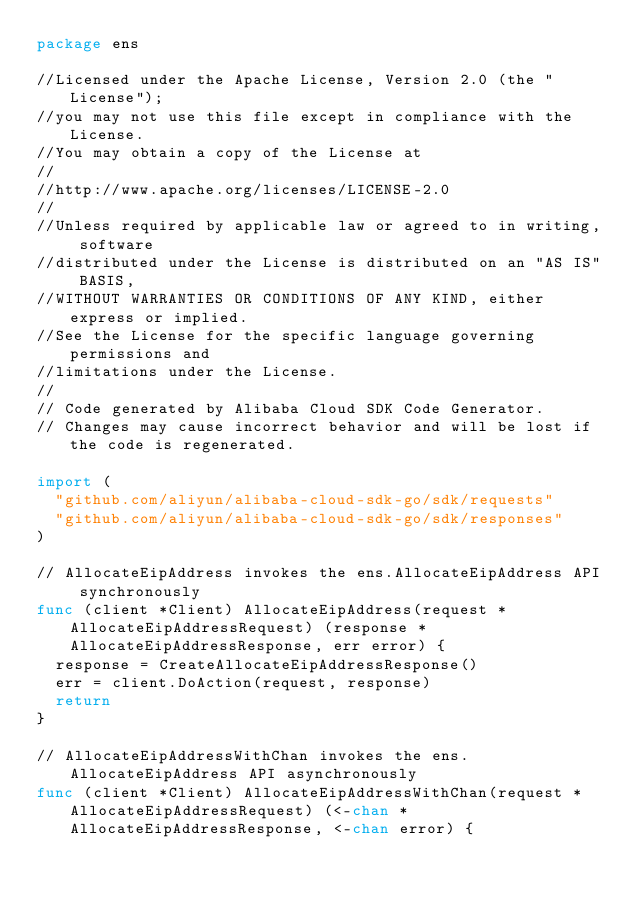Convert code to text. <code><loc_0><loc_0><loc_500><loc_500><_Go_>package ens

//Licensed under the Apache License, Version 2.0 (the "License");
//you may not use this file except in compliance with the License.
//You may obtain a copy of the License at
//
//http://www.apache.org/licenses/LICENSE-2.0
//
//Unless required by applicable law or agreed to in writing, software
//distributed under the License is distributed on an "AS IS" BASIS,
//WITHOUT WARRANTIES OR CONDITIONS OF ANY KIND, either express or implied.
//See the License for the specific language governing permissions and
//limitations under the License.
//
// Code generated by Alibaba Cloud SDK Code Generator.
// Changes may cause incorrect behavior and will be lost if the code is regenerated.

import (
	"github.com/aliyun/alibaba-cloud-sdk-go/sdk/requests"
	"github.com/aliyun/alibaba-cloud-sdk-go/sdk/responses"
)

// AllocateEipAddress invokes the ens.AllocateEipAddress API synchronously
func (client *Client) AllocateEipAddress(request *AllocateEipAddressRequest) (response *AllocateEipAddressResponse, err error) {
	response = CreateAllocateEipAddressResponse()
	err = client.DoAction(request, response)
	return
}

// AllocateEipAddressWithChan invokes the ens.AllocateEipAddress API asynchronously
func (client *Client) AllocateEipAddressWithChan(request *AllocateEipAddressRequest) (<-chan *AllocateEipAddressResponse, <-chan error) {</code> 